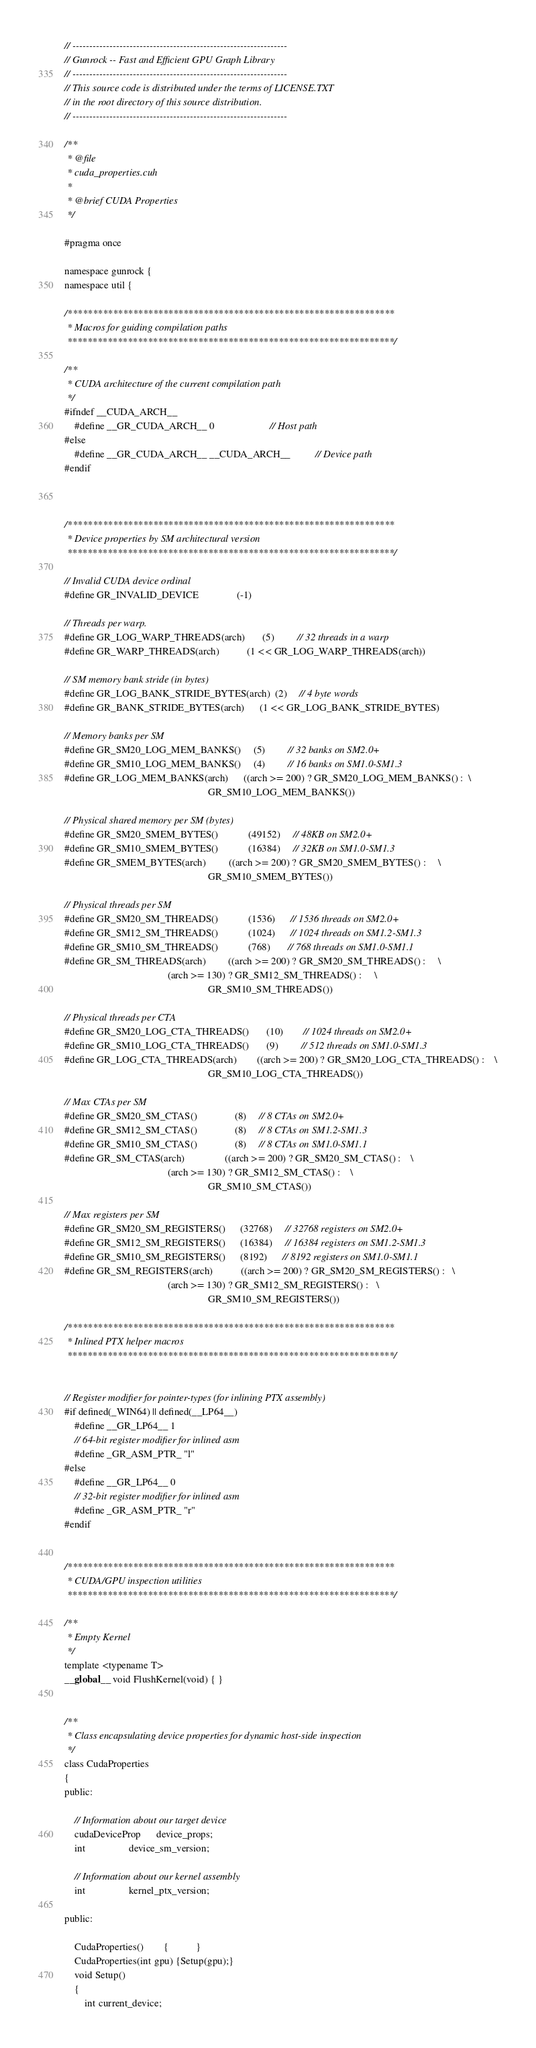Convert code to text. <code><loc_0><loc_0><loc_500><loc_500><_Cuda_>// ----------------------------------------------------------------
// Gunrock -- Fast and Efficient GPU Graph Library
// ----------------------------------------------------------------
// This source code is distributed under the terms of LICENSE.TXT
// in the root directory of this source distribution.
// ----------------------------------------------------------------

/**
 * @file
 * cuda_properties.cuh
 *
 * @brief CUDA Properties
 */

#pragma once

namespace gunrock {
namespace util {

/*****************************************************************
 * Macros for guiding compilation paths
 *****************************************************************/

/**
 * CUDA architecture of the current compilation path
 */
#ifndef __CUDA_ARCH__
    #define __GR_CUDA_ARCH__ 0                      // Host path
#else
    #define __GR_CUDA_ARCH__ __CUDA_ARCH__          // Device path
#endif



/*****************************************************************
 * Device properties by SM architectural version
 *****************************************************************/

// Invalid CUDA device ordinal
#define GR_INVALID_DEVICE               (-1)

// Threads per warp. 
#define GR_LOG_WARP_THREADS(arch)       (5)         // 32 threads in a warp 
#define GR_WARP_THREADS(arch)           (1 << GR_LOG_WARP_THREADS(arch))

// SM memory bank stride (in bytes)
#define GR_LOG_BANK_STRIDE_BYTES(arch)  (2)     // 4 byte words
#define GR_BANK_STRIDE_BYTES(arch)      (1 << GR_LOG_BANK_STRIDE_BYTES)

// Memory banks per SM
#define GR_SM20_LOG_MEM_BANKS()     (5)         // 32 banks on SM2.0+
#define GR_SM10_LOG_MEM_BANKS()     (4)         // 16 banks on SM1.0-SM1.3
#define GR_LOG_MEM_BANKS(arch)      ((arch >= 200) ? GR_SM20_LOG_MEM_BANKS() :  \
                                                         GR_SM10_LOG_MEM_BANKS())       

// Physical shared memory per SM (bytes)
#define GR_SM20_SMEM_BYTES()            (49152)     // 48KB on SM2.0+
#define GR_SM10_SMEM_BYTES()            (16384)     // 32KB on SM1.0-SM1.3
#define GR_SMEM_BYTES(arch)         ((arch >= 200) ? GR_SM20_SMEM_BYTES() :     \
                                                         GR_SM10_SMEM_BYTES())      

// Physical threads per SM
#define GR_SM20_SM_THREADS()            (1536)      // 1536 threads on SM2.0+
#define GR_SM12_SM_THREADS()            (1024)      // 1024 threads on SM1.2-SM1.3
#define GR_SM10_SM_THREADS()            (768)       // 768 threads on SM1.0-SM1.1
#define GR_SM_THREADS(arch)         ((arch >= 200) ? GR_SM20_SM_THREADS() :     \
                                         (arch >= 130) ? GR_SM12_SM_THREADS() :     \
                                                         GR_SM10_SM_THREADS())

// Physical threads per CTA
#define GR_SM20_LOG_CTA_THREADS()       (10)        // 1024 threads on SM2.0+
#define GR_SM10_LOG_CTA_THREADS()       (9)         // 512 threads on SM1.0-SM1.3
#define GR_LOG_CTA_THREADS(arch)        ((arch >= 200) ? GR_SM20_LOG_CTA_THREADS() :    \
                                                         GR_SM10_LOG_CTA_THREADS())

// Max CTAs per SM
#define GR_SM20_SM_CTAS()               (8)     // 8 CTAs on SM2.0+
#define GR_SM12_SM_CTAS()               (8)     // 8 CTAs on SM1.2-SM1.3
#define GR_SM10_SM_CTAS()               (8)     // 8 CTAs on SM1.0-SM1.1
#define GR_SM_CTAS(arch)                ((arch >= 200) ? GR_SM20_SM_CTAS() :    \
                                         (arch >= 130) ? GR_SM12_SM_CTAS() :    \
                                                         GR_SM10_SM_CTAS())

// Max registers per SM
#define GR_SM20_SM_REGISTERS()      (32768)     // 32768 registers on SM2.0+
#define GR_SM12_SM_REGISTERS()      (16384)     // 16384 registers on SM1.2-SM1.3
#define GR_SM10_SM_REGISTERS()      (8192)      // 8192 registers on SM1.0-SM1.1
#define GR_SM_REGISTERS(arch)           ((arch >= 200) ? GR_SM20_SM_REGISTERS() :   \
                                         (arch >= 130) ? GR_SM12_SM_REGISTERS() :   \
                                                         GR_SM10_SM_REGISTERS())

/*****************************************************************
 * Inlined PTX helper macros
 *****************************************************************/


// Register modifier for pointer-types (for inlining PTX assembly)
#if defined(_WIN64) || defined(__LP64__)
    #define __GR_LP64__ 1
    // 64-bit register modifier for inlined asm
    #define _GR_ASM_PTR_ "l"
#else
    #define __GR_LP64__ 0
    // 32-bit register modifier for inlined asm
    #define _GR_ASM_PTR_ "r"
#endif


/*****************************************************************
 * CUDA/GPU inspection utilities
 *****************************************************************/

/**
 * Empty Kernel
 */
template <typename T>
__global__ void FlushKernel(void) { }


/**
 * Class encapsulating device properties for dynamic host-side inspection
 */
class CudaProperties 
{
public:
    
    // Information about our target device
    cudaDeviceProp      device_props;
    int                 device_sm_version;
    
    // Information about our kernel assembly
    int                 kernel_ptx_version;
    
public:

    CudaProperties()        {           }
    CudaProperties(int gpu) {Setup(gpu);}
    void Setup()
    {
        int current_device;</code> 